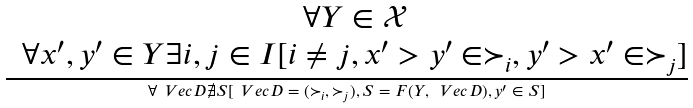Convert formula to latex. <formula><loc_0><loc_0><loc_500><loc_500>\frac { \begin{matrix} & \forall Y \in \mathcal { X } \\ & \forall x ^ { \prime } , y ^ { \prime } \in Y \exists i , j \in I [ i \ne j , x ^ { \prime } > y ^ { \prime } \in \succ _ { i } , y ^ { \prime } > x ^ { \prime } \in \succ _ { j } ] \end{matrix} } { \forall \ V e c { D } \nexists S [ \ V e c { D } = ( \succ _ { i } , \succ _ { j } ) , S = F ( Y , \ V e c { D } ) , y ^ { \prime } \in S ] }</formula> 